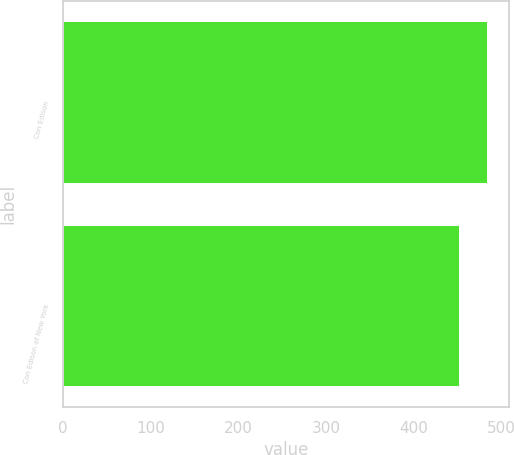Convert chart to OTSL. <chart><loc_0><loc_0><loc_500><loc_500><bar_chart><fcel>Con Edison<fcel>Con Edison of New York<nl><fcel>485<fcel>453<nl></chart> 